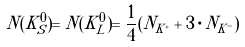<formula> <loc_0><loc_0><loc_500><loc_500>N ( K _ { S } ^ { 0 } ) = N ( K _ { L } ^ { 0 } ) = \frac { 1 } { 4 } ( N _ { K ^ { + } } + 3 \cdot N _ { K ^ { - } } )</formula> 